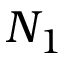Convert formula to latex. <formula><loc_0><loc_0><loc_500><loc_500>N _ { 1 }</formula> 